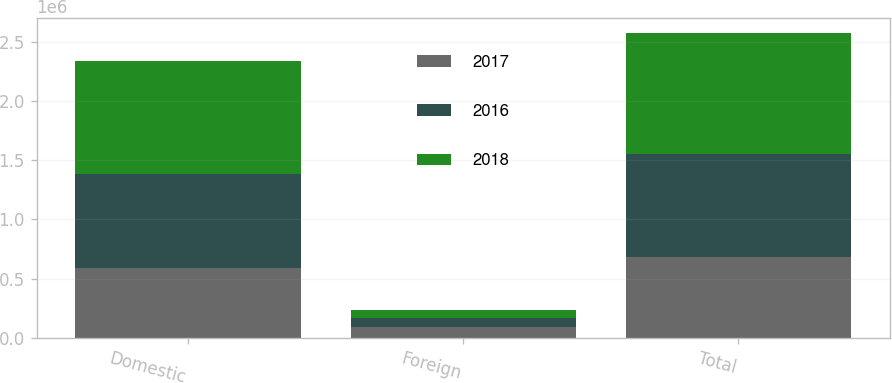Convert chart. <chart><loc_0><loc_0><loc_500><loc_500><stacked_bar_chart><ecel><fcel>Domestic<fcel>Foreign<fcel>Total<nl><fcel>2017<fcel>593099<fcel>93530<fcel>686629<nl><fcel>2016<fcel>788878<fcel>74961<fcel>863839<nl><fcel>2018<fcel>954138<fcel>69773<fcel>1.02391e+06<nl></chart> 